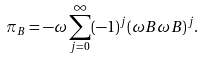Convert formula to latex. <formula><loc_0><loc_0><loc_500><loc_500>\pi _ { B } = - \omega \sum _ { j = 0 } ^ { \infty } ( - 1 ) ^ { j } ( \omega B \omega B ) ^ { j } .</formula> 